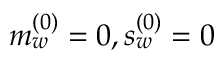Convert formula to latex. <formula><loc_0><loc_0><loc_500><loc_500>m _ { w } ^ { ( 0 ) } = 0 , s _ { w } ^ { ( 0 ) } = 0</formula> 